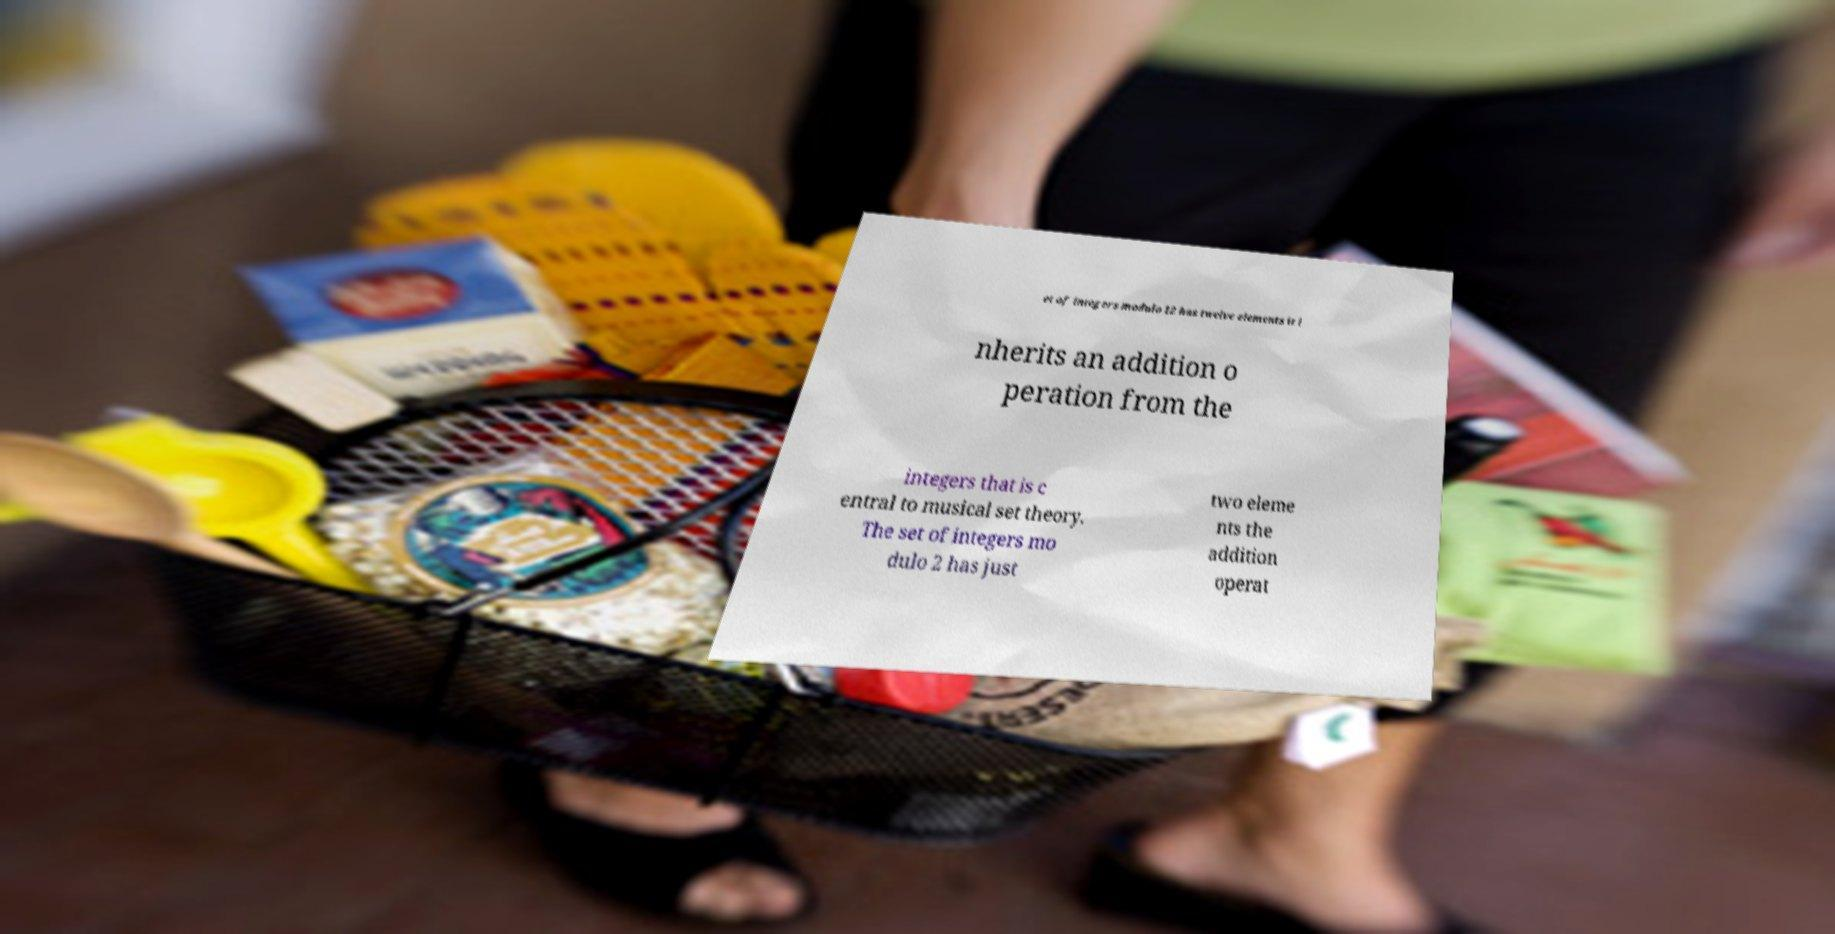Please identify and transcribe the text found in this image. et of integers modulo 12 has twelve elements it i nherits an addition o peration from the integers that is c entral to musical set theory. The set of integers mo dulo 2 has just two eleme nts the addition operat 